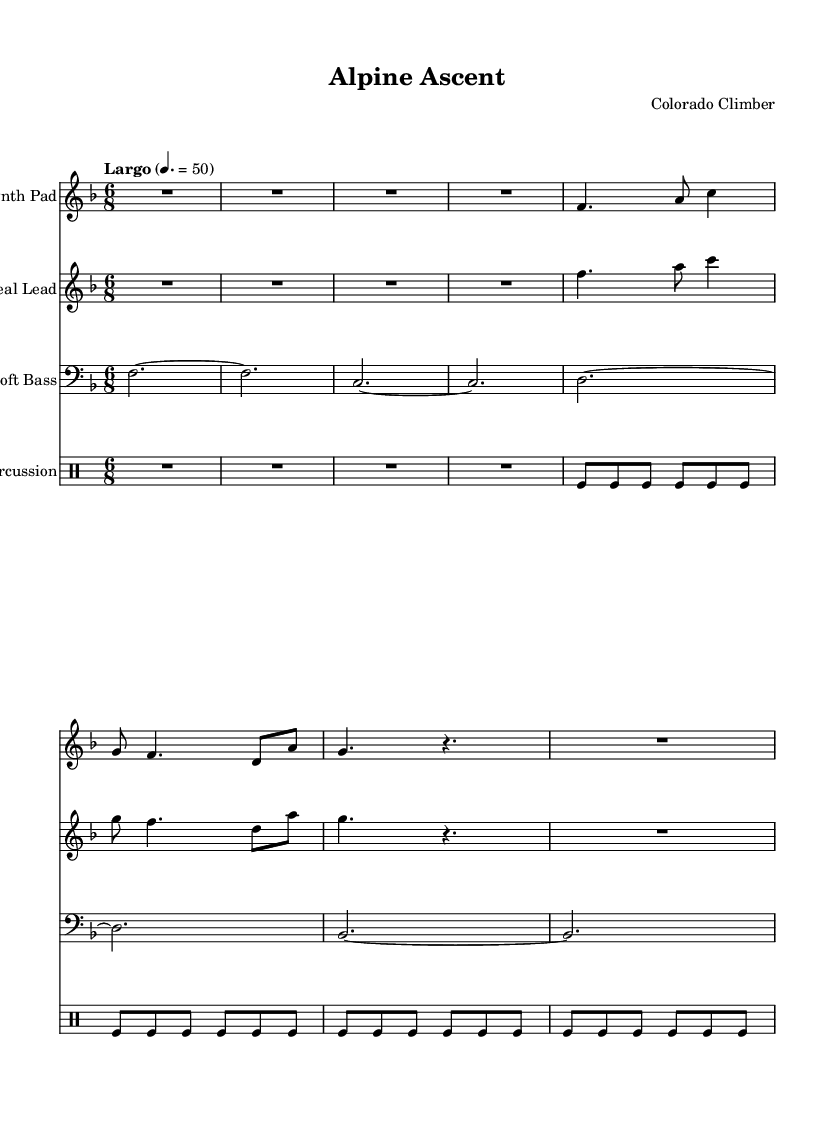What is the key signature of this music? The key signature is F major, which has one flat (B flat) indicated at the beginning of the staff.
Answer: F major What is the time signature of this piece? The time signature is 6/8, as shown at the beginning of the sheet music, indicating there are six eighth notes per measure.
Answer: 6/8 What is the tempo marking for this composition? The tempo marking is "Largo," which is indicated above the staff and suggests a slow pace.
Answer: Largo Which instrument is identified as "Soft Bass" in the score? The score indicates that "Soft Bass" is written in the bass clef staff, which is specifically labeled as the instrument name.
Answer: Bass How many measures are in the "Synth Pad" section? The "Synth Pad" section contains a total of four measures based on the visual division of bars on the staff.
Answer: 4 What type of percussion is used in the "Gentle Percussion" part? The score specifies "tomfl," referring to the use of tom-toms for light percussion effects, commonly used in ambient electronic music.
Answer: Tom-toms What is the rhythmic pattern of the "Ethereal Lead" compared to the "Synth Pad"? Both the "Ethereal Lead" and "Synth Pad" share identical melodic lines and rhythmic patterns, suggesting they are designed to complement each other.
Answer: Identical 